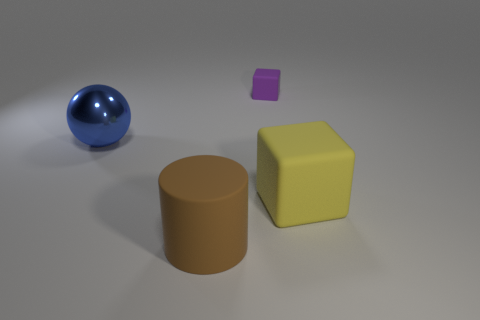Add 4 yellow cubes. How many objects exist? 8 Subtract all cylinders. How many objects are left? 3 Add 3 tiny green matte cylinders. How many tiny green matte cylinders exist? 3 Subtract 0 gray spheres. How many objects are left? 4 Subtract all small purple matte cylinders. Subtract all rubber cylinders. How many objects are left? 3 Add 4 brown rubber objects. How many brown rubber objects are left? 5 